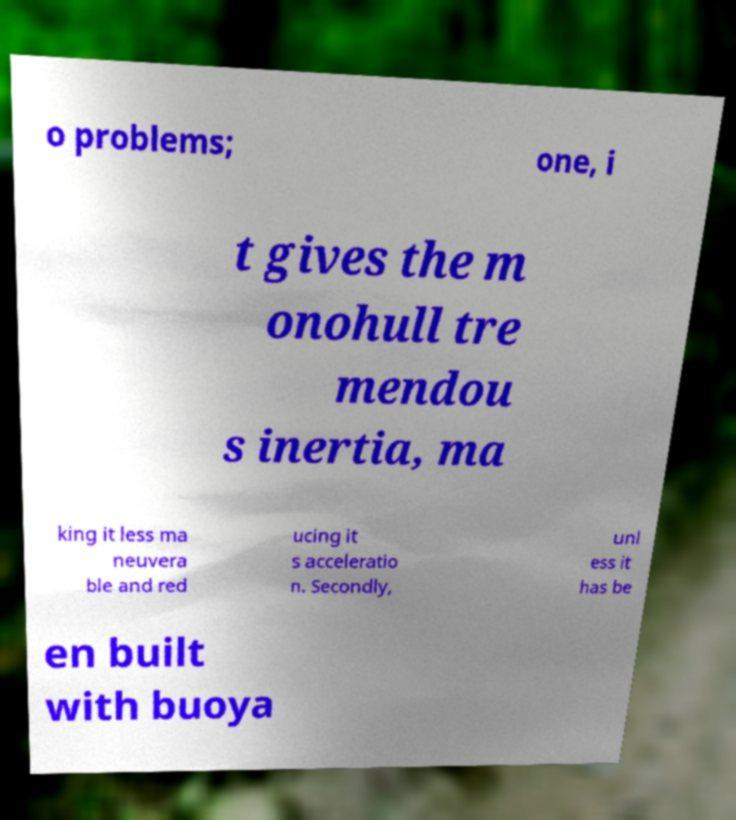Please read and relay the text visible in this image. What does it say? o problems; one, i t gives the m onohull tre mendou s inertia, ma king it less ma neuvera ble and red ucing it s acceleratio n. Secondly, unl ess it has be en built with buoya 